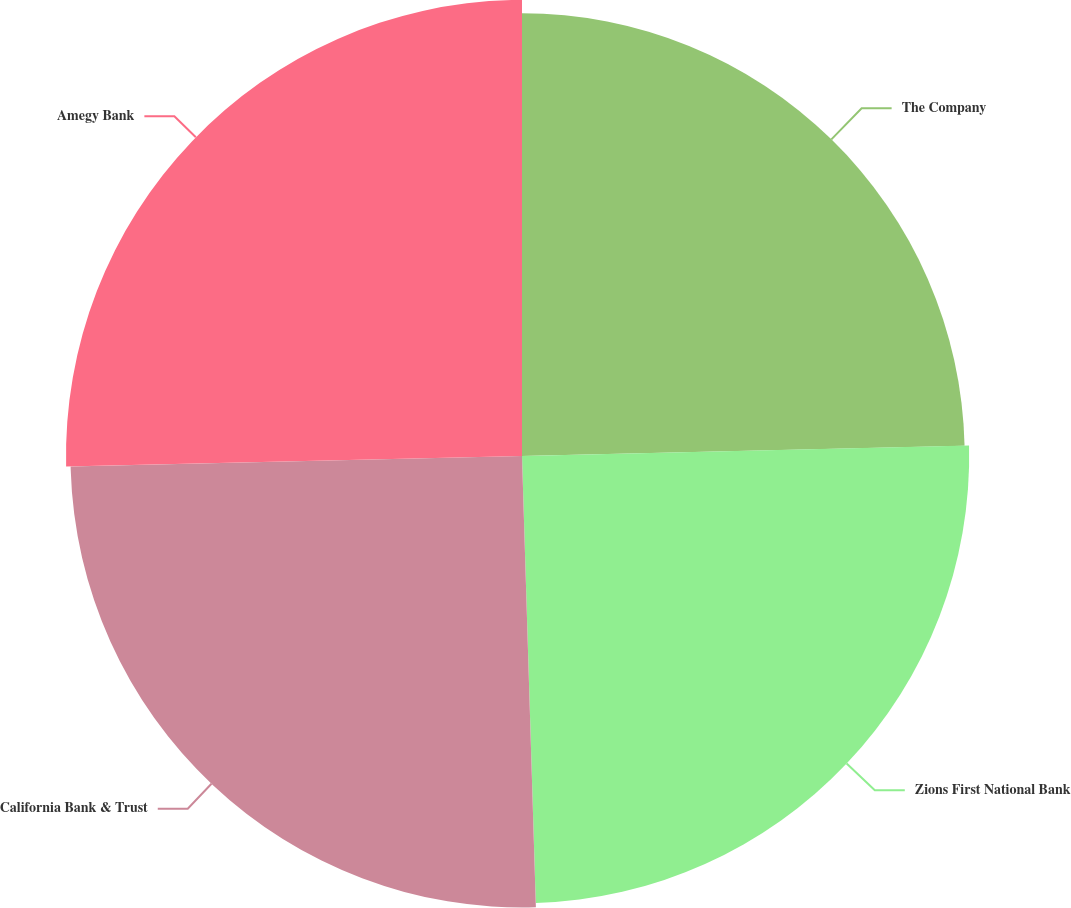Convert chart. <chart><loc_0><loc_0><loc_500><loc_500><pie_chart><fcel>The Company<fcel>Zions First National Bank<fcel>California Bank & Trust<fcel>Amegy Bank<nl><fcel>24.63%<fcel>24.88%<fcel>25.12%<fcel>25.37%<nl></chart> 